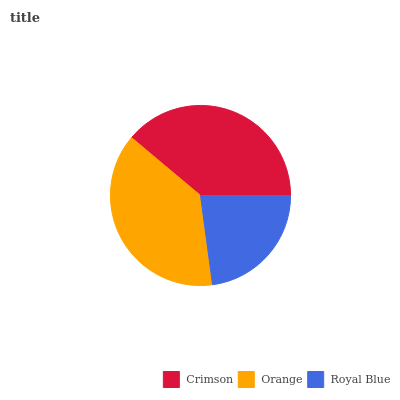Is Royal Blue the minimum?
Answer yes or no. Yes. Is Crimson the maximum?
Answer yes or no. Yes. Is Orange the minimum?
Answer yes or no. No. Is Orange the maximum?
Answer yes or no. No. Is Crimson greater than Orange?
Answer yes or no. Yes. Is Orange less than Crimson?
Answer yes or no. Yes. Is Orange greater than Crimson?
Answer yes or no. No. Is Crimson less than Orange?
Answer yes or no. No. Is Orange the high median?
Answer yes or no. Yes. Is Orange the low median?
Answer yes or no. Yes. Is Crimson the high median?
Answer yes or no. No. Is Crimson the low median?
Answer yes or no. No. 